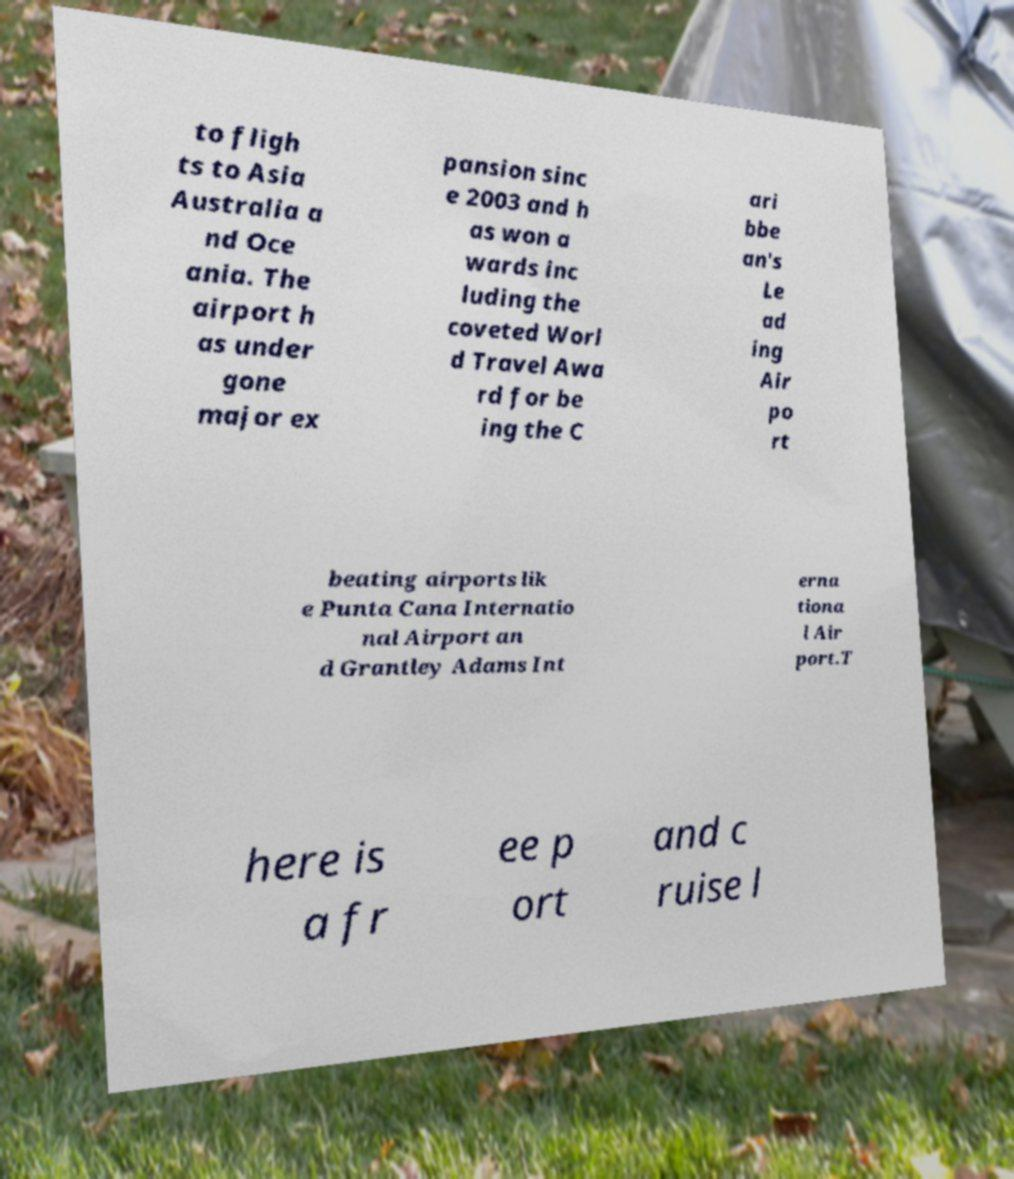For documentation purposes, I need the text within this image transcribed. Could you provide that? to fligh ts to Asia Australia a nd Oce ania. The airport h as under gone major ex pansion sinc e 2003 and h as won a wards inc luding the coveted Worl d Travel Awa rd for be ing the C ari bbe an's Le ad ing Air po rt beating airports lik e Punta Cana Internatio nal Airport an d Grantley Adams Int erna tiona l Air port.T here is a fr ee p ort and c ruise l 